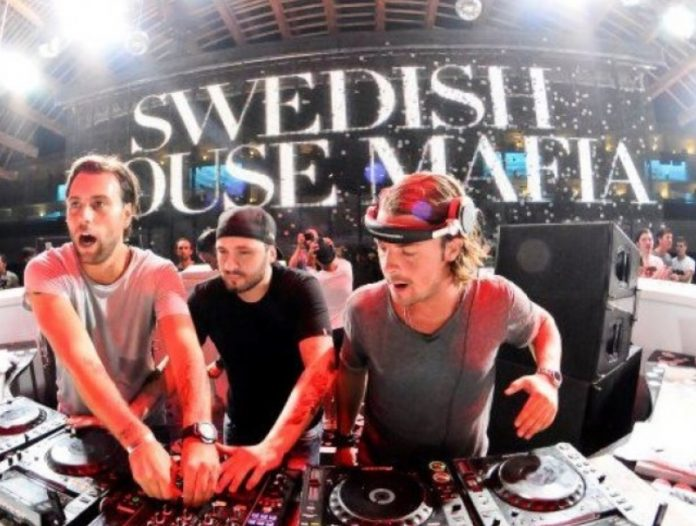What can you tell about the cultural or social significance of the event depicted in the image? The event depicted in the image appears to be a significant cultural gathering, particularly within the realm of electronic dance music (EDM). This genre of music has a global following and often serves as a platform for cultural expression and social interaction. The presence of 'Swedish House Mafia,' a globally recognized music group, suggests the event is of considerable importance, likely drawing a diverse audience of fans. Such events are not just about music; they are social experiences that foster a sense of community among attendees. The intense lighting, sophisticated sound equipment, and engaged crowd highlight the modern culture of live musical performances, where technology and artistry merge to create immersive experiences. How do you think the popularity of such events influences the local culture? The popularity of events like this one likely has a substantial influence on the local culture. They serve as hubs for cultural exchange, where individuals from various backgrounds come together to share a common interest in music. This can lead to a more cohesive community identity centered around a shared passion for EDM. Additionally, the influx of fans from different regions can introduce new ideas, fashions, and attitudes, further enriching the local cultural landscape. For the local economy, such events can boost businesses, including hospitality, transportation, and retail sectors, given the demand generated by attendees. Over time, these gatherings help cultivate a vibrant, dynamic cultural scene that is both inclusive and forward-looking. Create a short story set in this concert from the perspective of a first-time attendee. Alex had always been curious about the hype surrounding EDM concerts but had never experienced one firsthand. As a birthday surprise, his friends decided to take him to see the legendary 'Swedish House Mafia' perform live. As they walked into the venue, Alex was immediately taken aback by the sheer scale of it all—the enormous stage, the dazzling lights, and the sea of people moving to the beat of the music. With each pulse of the bass, he felt vibrations travel through his entire body, making him feel more alive than ever. As the music intensified, he found himself losing track of time, completely absorbed in the electrifying atmosphere. By the end of the night, Alex knew he had found a new passion and couldn't wait to attend another concert. Imagine the event five years in the future. How might it look different? Five years in the future, such an event could be even more technologically advanced and immersive. Imagine an environment where augmented reality (AR) and virtual reality (VR) integrate with live performances. Attendees might wear AR glasses that enhance visual effects or participate in VR experiences that make remote attendees feel like they're part of the live crowd. The music might be accompanied by holographic displays, and the sound systems could be more advanced, providing a fully enveloping audio experience. Innovations in interactive elements could allow fans to influence the performance through real-time feedback. These technological advancements would not only enhance sensory experiences but also democratize access to such high-profile concerts, enabling fans worldwide to participate virtually. 